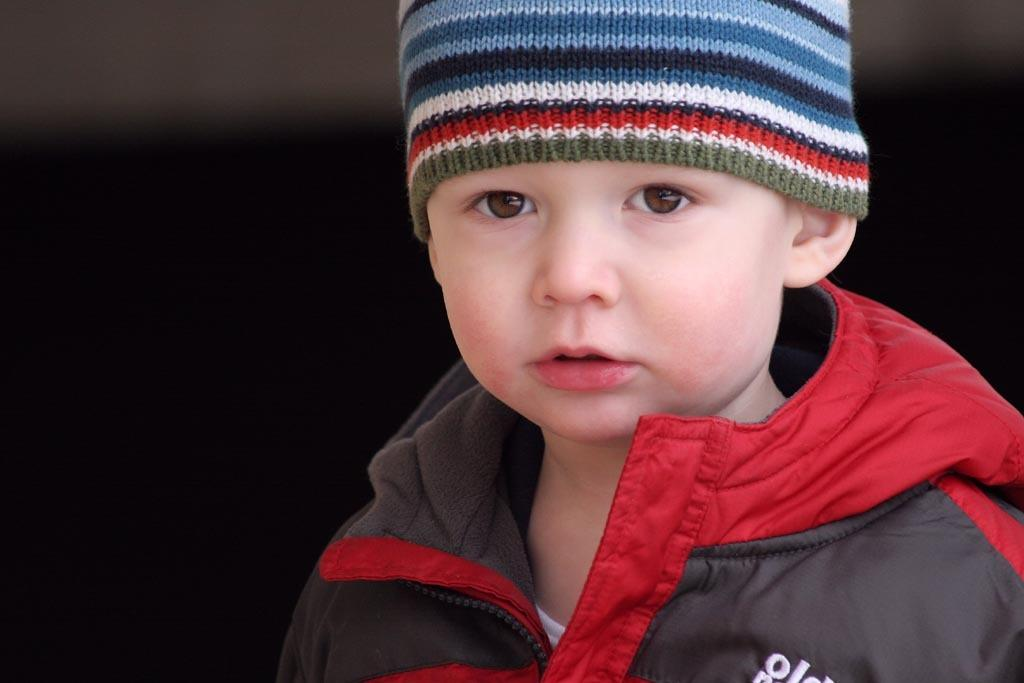What is the main subject of the image? The main subject of the image is a kid. What is the kid doing in the image? The kid is watching something. What clothing items is the kid wearing? The kid is wearing a jacket and a cap. Can you describe the background of the image? The background of the image is dark. What type of metal can be seen in the image? There is no metal present in the image. What is the kid using to carry a heavy load in the image? There is no yoke or heavy load present in the image. 